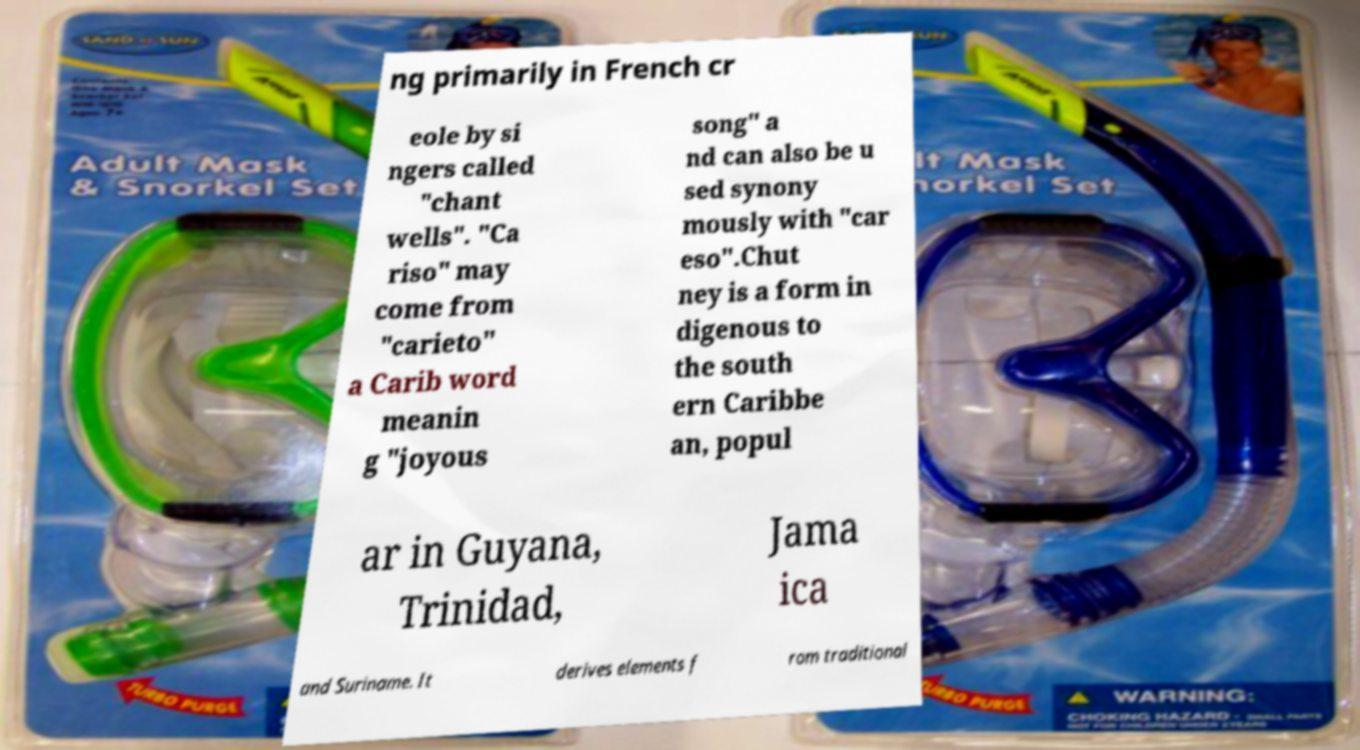What messages or text are displayed in this image? I need them in a readable, typed format. ng primarily in French cr eole by si ngers called "chant wells". "Ca riso" may come from "carieto" a Carib word meanin g "joyous song" a nd can also be u sed synony mously with "car eso".Chut ney is a form in digenous to the south ern Caribbe an, popul ar in Guyana, Trinidad, Jama ica and Suriname. It derives elements f rom traditional 